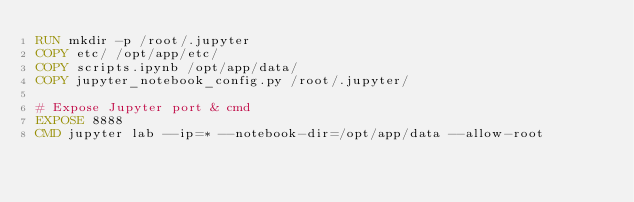<code> <loc_0><loc_0><loc_500><loc_500><_Dockerfile_>RUN mkdir -p /root/.jupyter
COPY etc/ /opt/app/etc/
COPY scripts.ipynb /opt/app/data/
COPY jupyter_notebook_config.py /root/.jupyter/

# Expose Jupyter port & cmd
EXPOSE 8888
CMD jupyter lab --ip=* --notebook-dir=/opt/app/data --allow-root
</code> 